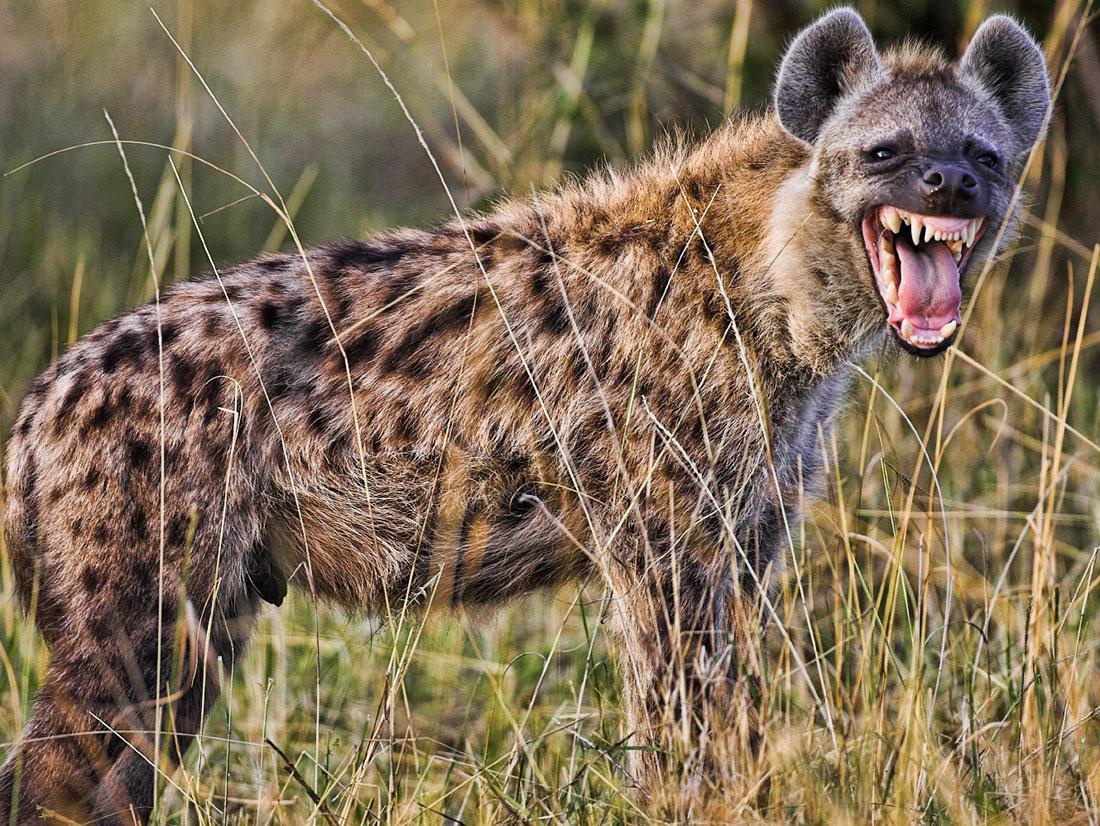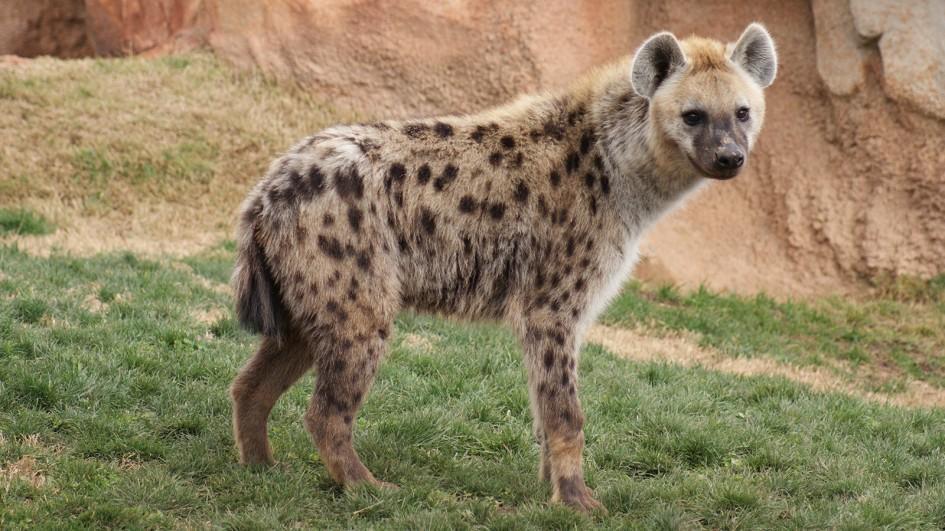The first image is the image on the left, the second image is the image on the right. Evaluate the accuracy of this statement regarding the images: "In one of the images, there is one hyena with its mouth open bearing its teeth". Is it true? Answer yes or no. Yes. 